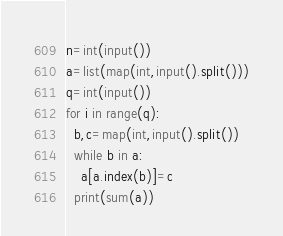<code> <loc_0><loc_0><loc_500><loc_500><_Python_>n=int(input())
a=list(map(int,input().split()))
q=int(input())
for i in range(q):
  b,c=map(int,input().split())
  while b in a:
    a[a.index(b)]=c
  print(sum(a))</code> 